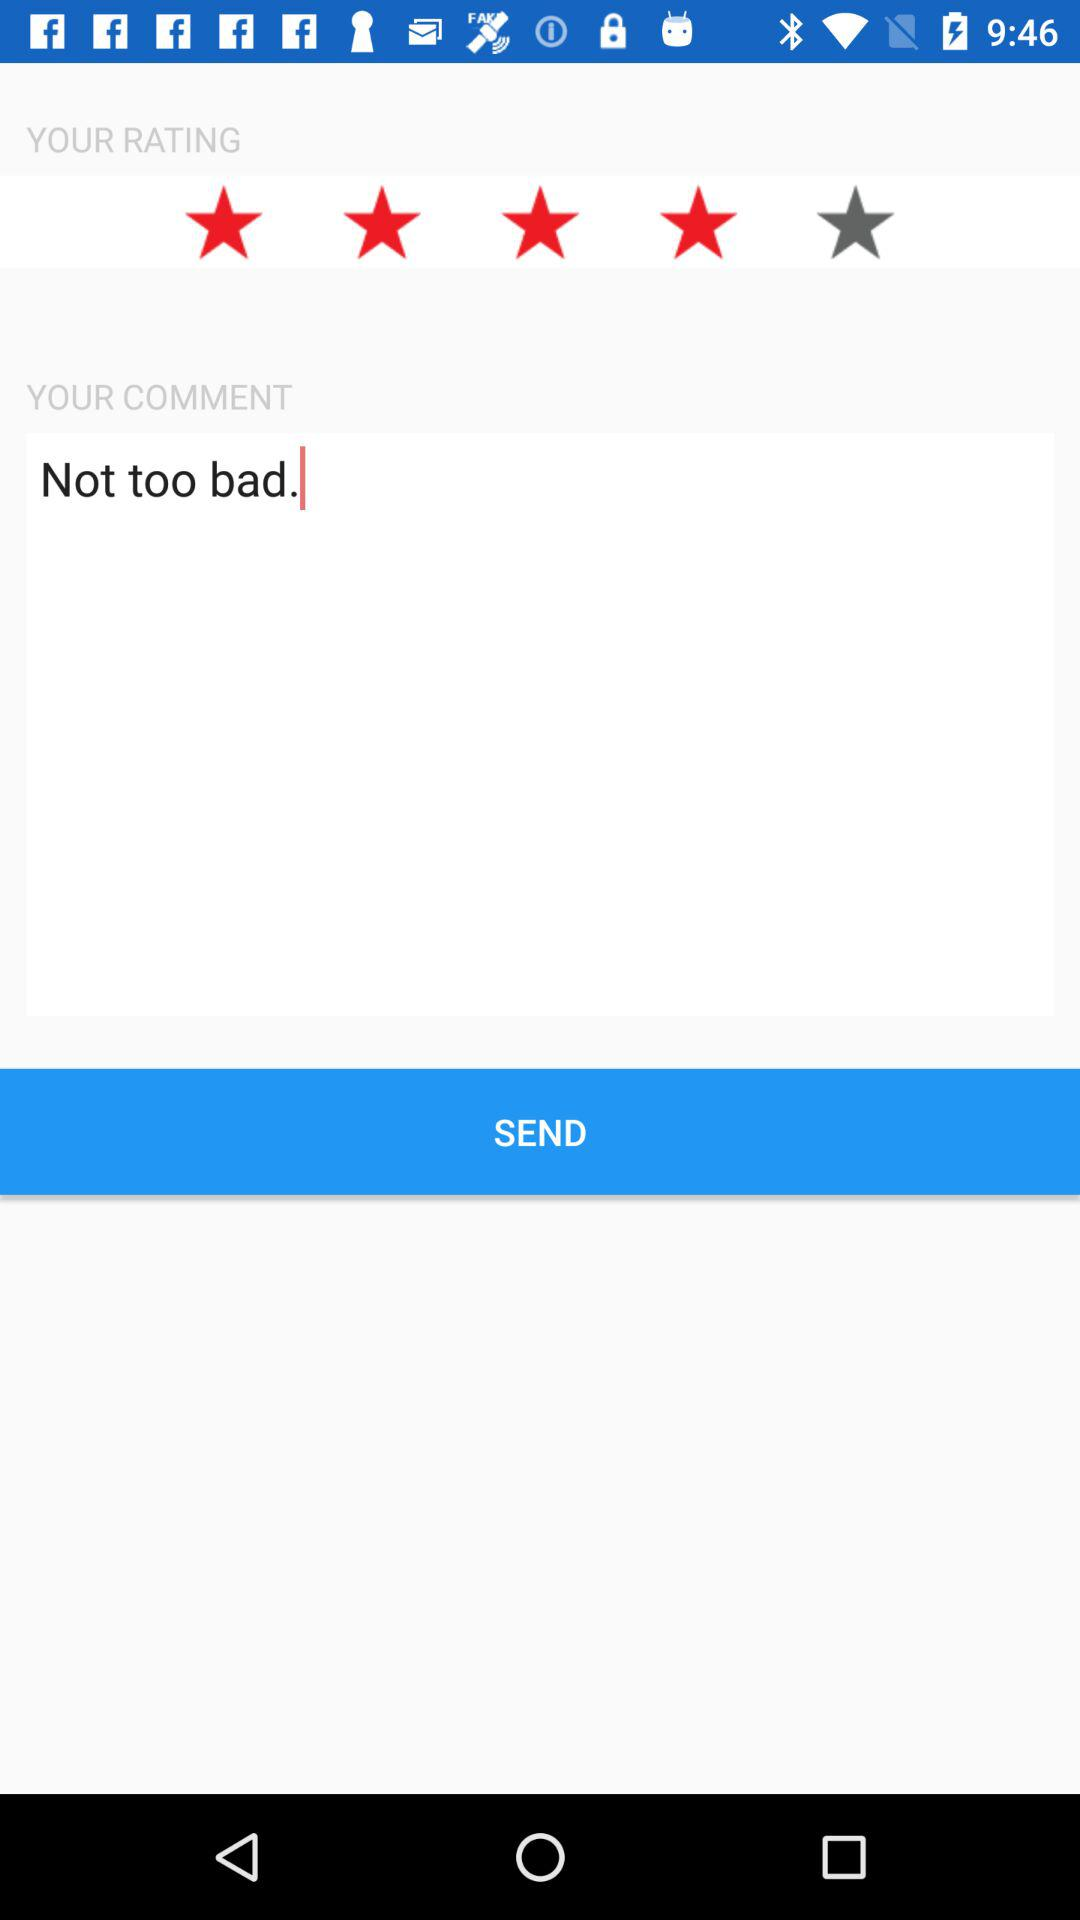Was the comment sent?
When the provided information is insufficient, respond with <no answer>. <no answer> 